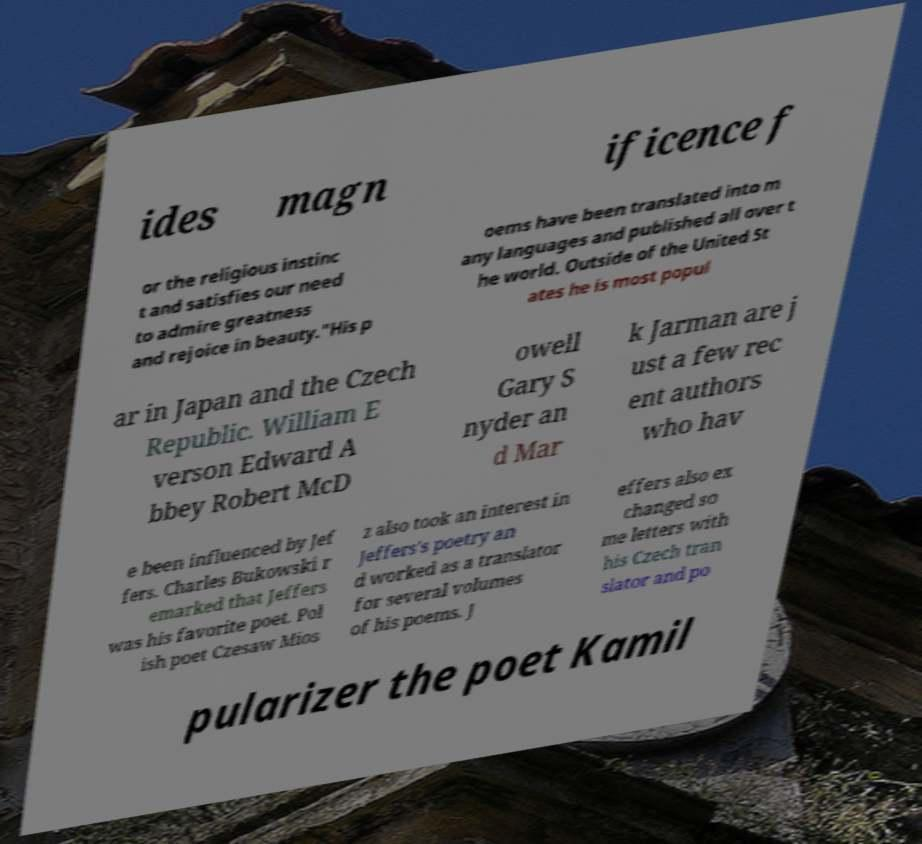What messages or text are displayed in this image? I need them in a readable, typed format. ides magn ificence f or the religious instinc t and satisfies our need to admire greatness and rejoice in beauty."His p oems have been translated into m any languages and published all over t he world. Outside of the United St ates he is most popul ar in Japan and the Czech Republic. William E verson Edward A bbey Robert McD owell Gary S nyder an d Mar k Jarman are j ust a few rec ent authors who hav e been influenced by Jef fers. Charles Bukowski r emarked that Jeffers was his favorite poet. Pol ish poet Czesaw Mios z also took an interest in Jeffers's poetry an d worked as a translator for several volumes of his poems. J effers also ex changed so me letters with his Czech tran slator and po pularizer the poet Kamil 